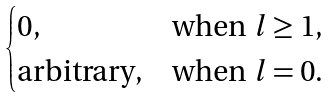Convert formula to latex. <formula><loc_0><loc_0><loc_500><loc_500>\begin{cases} 0 , & \text {when $l \geq 1$} , \\ \text {arbitrary} , & \text {when $l=0$} . \end{cases}</formula> 